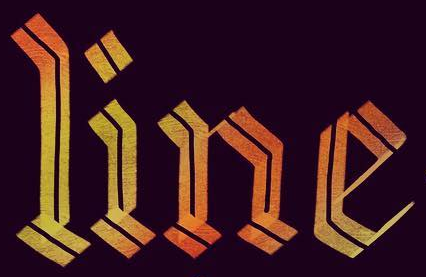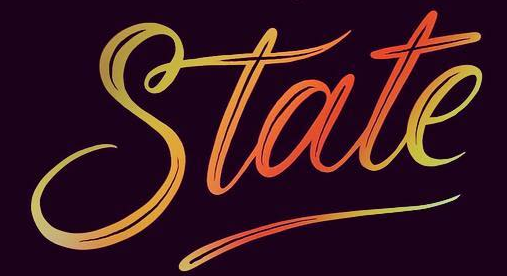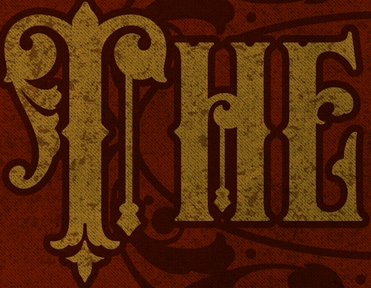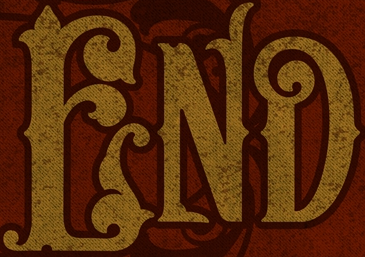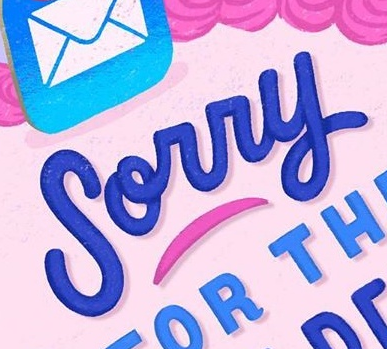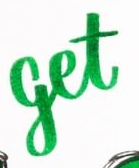Transcribe the words shown in these images in order, separated by a semicolon. line; State; THE; END; Sorry; get 